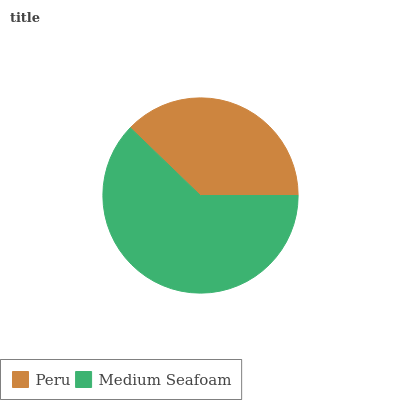Is Peru the minimum?
Answer yes or no. Yes. Is Medium Seafoam the maximum?
Answer yes or no. Yes. Is Medium Seafoam the minimum?
Answer yes or no. No. Is Medium Seafoam greater than Peru?
Answer yes or no. Yes. Is Peru less than Medium Seafoam?
Answer yes or no. Yes. Is Peru greater than Medium Seafoam?
Answer yes or no. No. Is Medium Seafoam less than Peru?
Answer yes or no. No. Is Medium Seafoam the high median?
Answer yes or no. Yes. Is Peru the low median?
Answer yes or no. Yes. Is Peru the high median?
Answer yes or no. No. Is Medium Seafoam the low median?
Answer yes or no. No. 